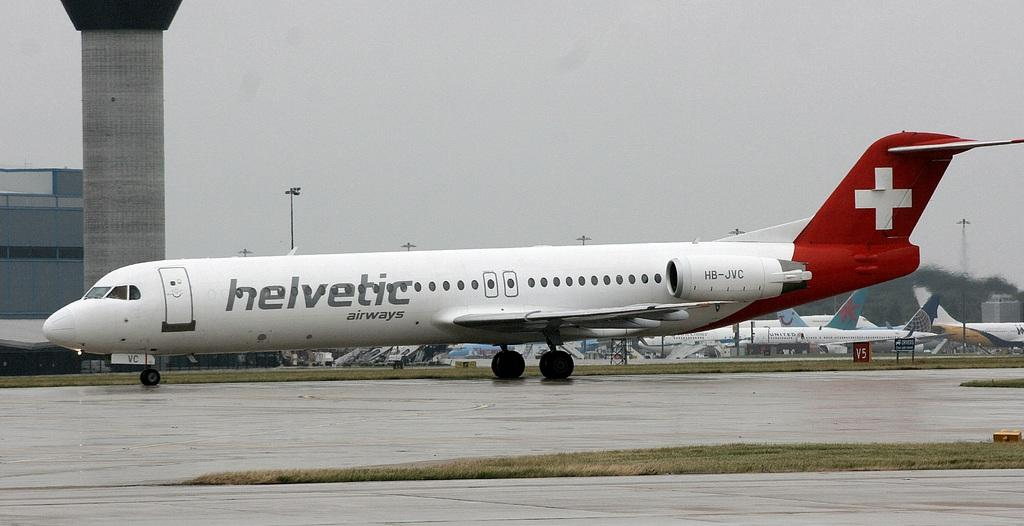<image>
Present a compact description of the photo's key features. a plane that says 'helvetic airways' on the side of it 